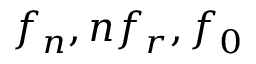Convert formula to latex. <formula><loc_0><loc_0><loc_500><loc_500>f _ { n } , n f _ { r } , f _ { 0 }</formula> 